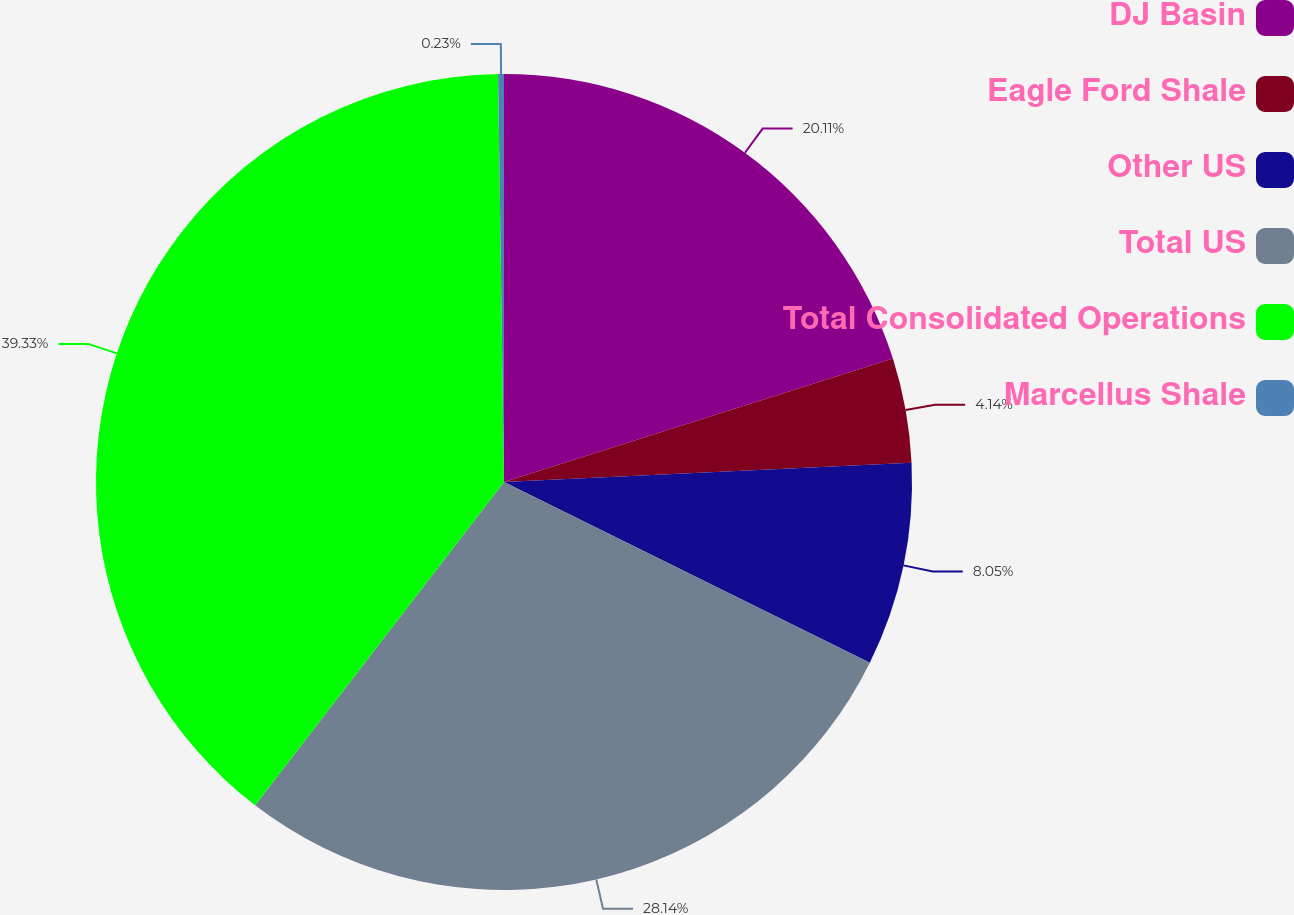Convert chart to OTSL. <chart><loc_0><loc_0><loc_500><loc_500><pie_chart><fcel>DJ Basin<fcel>Eagle Ford Shale<fcel>Other US<fcel>Total US<fcel>Total Consolidated Operations<fcel>Marcellus Shale<nl><fcel>20.11%<fcel>4.14%<fcel>8.05%<fcel>28.14%<fcel>39.33%<fcel>0.23%<nl></chart> 